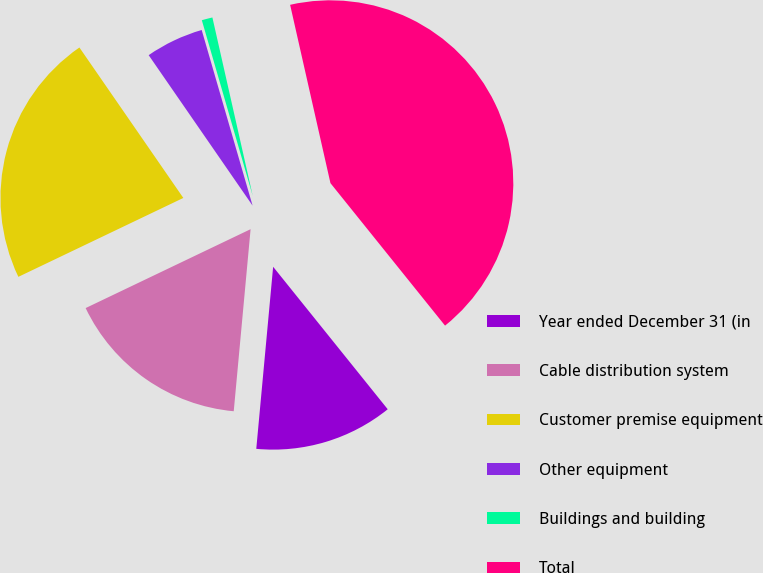Convert chart to OTSL. <chart><loc_0><loc_0><loc_500><loc_500><pie_chart><fcel>Year ended December 31 (in<fcel>Cable distribution system<fcel>Customer premise equipment<fcel>Other equipment<fcel>Buildings and building<fcel>Total<nl><fcel>12.25%<fcel>16.43%<fcel>22.48%<fcel>5.13%<fcel>0.95%<fcel>42.76%<nl></chart> 